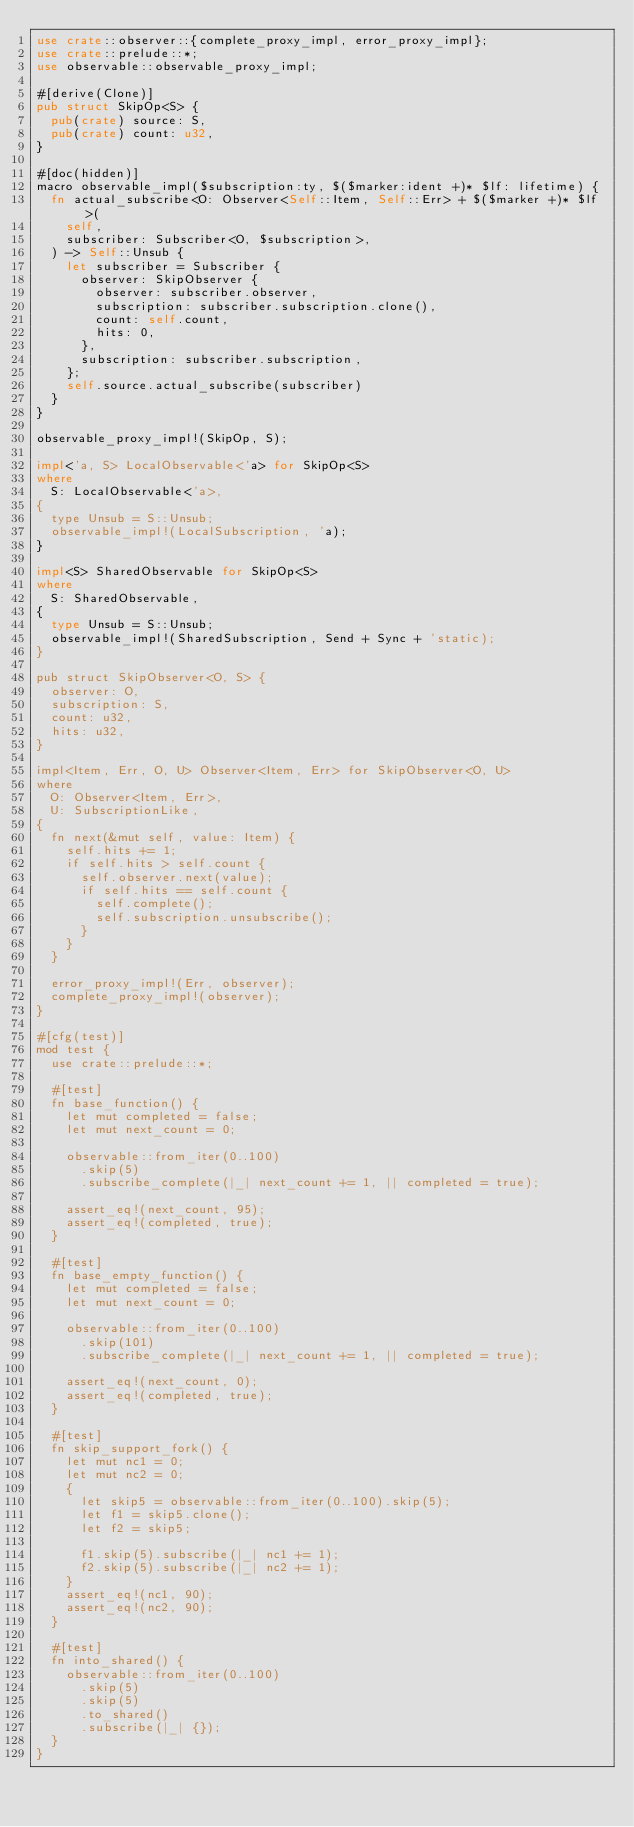<code> <loc_0><loc_0><loc_500><loc_500><_Rust_>use crate::observer::{complete_proxy_impl, error_proxy_impl};
use crate::prelude::*;
use observable::observable_proxy_impl;

#[derive(Clone)]
pub struct SkipOp<S> {
  pub(crate) source: S,
  pub(crate) count: u32,
}

#[doc(hidden)]
macro observable_impl($subscription:ty, $($marker:ident +)* $lf: lifetime) {
  fn actual_subscribe<O: Observer<Self::Item, Self::Err> + $($marker +)* $lf>(
    self,
    subscriber: Subscriber<O, $subscription>,
  ) -> Self::Unsub {
    let subscriber = Subscriber {
      observer: SkipObserver {
        observer: subscriber.observer,
        subscription: subscriber.subscription.clone(),
        count: self.count,
        hits: 0,
      },
      subscription: subscriber.subscription,
    };
    self.source.actual_subscribe(subscriber)
  }
}

observable_proxy_impl!(SkipOp, S);

impl<'a, S> LocalObservable<'a> for SkipOp<S>
where
  S: LocalObservable<'a>,
{
  type Unsub = S::Unsub;
  observable_impl!(LocalSubscription, 'a);
}

impl<S> SharedObservable for SkipOp<S>
where
  S: SharedObservable,
{
  type Unsub = S::Unsub;
  observable_impl!(SharedSubscription, Send + Sync + 'static);
}

pub struct SkipObserver<O, S> {
  observer: O,
  subscription: S,
  count: u32,
  hits: u32,
}

impl<Item, Err, O, U> Observer<Item, Err> for SkipObserver<O, U>
where
  O: Observer<Item, Err>,
  U: SubscriptionLike,
{
  fn next(&mut self, value: Item) {
    self.hits += 1;
    if self.hits > self.count {
      self.observer.next(value);
      if self.hits == self.count {
        self.complete();
        self.subscription.unsubscribe();
      }
    }
  }

  error_proxy_impl!(Err, observer);
  complete_proxy_impl!(observer);
}

#[cfg(test)]
mod test {
  use crate::prelude::*;

  #[test]
  fn base_function() {
    let mut completed = false;
    let mut next_count = 0;

    observable::from_iter(0..100)
      .skip(5)
      .subscribe_complete(|_| next_count += 1, || completed = true);

    assert_eq!(next_count, 95);
    assert_eq!(completed, true);
  }

  #[test]
  fn base_empty_function() {
    let mut completed = false;
    let mut next_count = 0;

    observable::from_iter(0..100)
      .skip(101)
      .subscribe_complete(|_| next_count += 1, || completed = true);

    assert_eq!(next_count, 0);
    assert_eq!(completed, true);
  }

  #[test]
  fn skip_support_fork() {
    let mut nc1 = 0;
    let mut nc2 = 0;
    {
      let skip5 = observable::from_iter(0..100).skip(5);
      let f1 = skip5.clone();
      let f2 = skip5;

      f1.skip(5).subscribe(|_| nc1 += 1);
      f2.skip(5).subscribe(|_| nc2 += 1);
    }
    assert_eq!(nc1, 90);
    assert_eq!(nc2, 90);
  }

  #[test]
  fn into_shared() {
    observable::from_iter(0..100)
      .skip(5)
      .skip(5)
      .to_shared()
      .subscribe(|_| {});
  }
}
</code> 